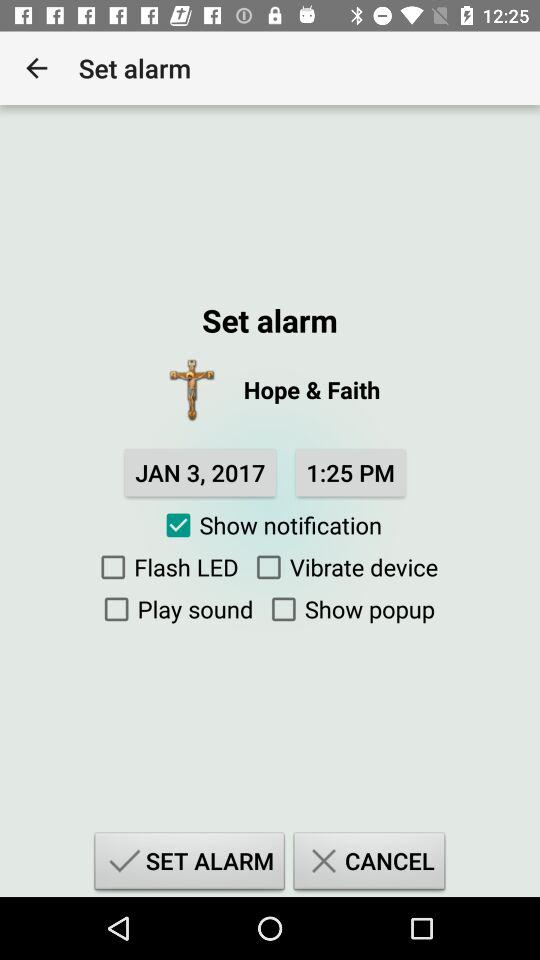Is "Show popup" checked or unchecked? "Show popup" is unchecked. 